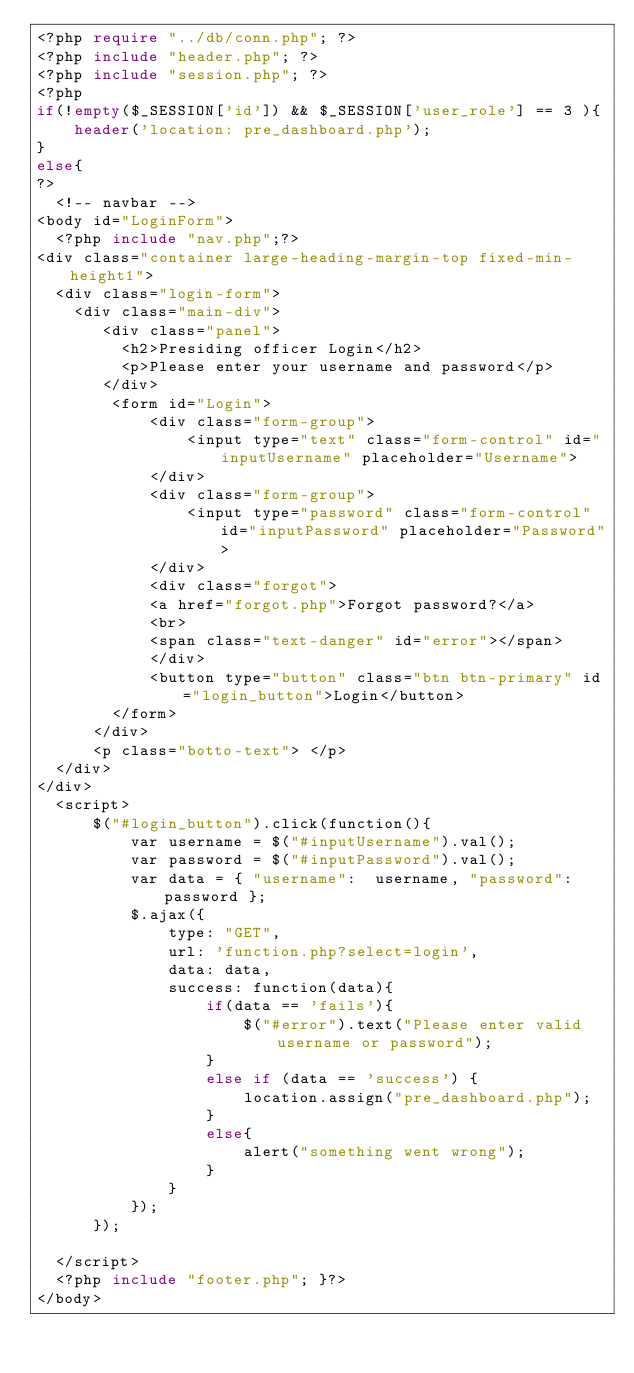<code> <loc_0><loc_0><loc_500><loc_500><_PHP_><?php require "../db/conn.php"; ?>
<?php include "header.php"; ?>
<?php include "session.php"; ?>
<?php
if(!empty($_SESSION['id']) && $_SESSION['user_role'] == 3 ){
    header('location: pre_dashboard.php');
}
else{
?>
  <!-- navbar -->
<body id="LoginForm">
  <?php include "nav.php";?>
<div class="container large-heading-margin-top fixed-min-height1">
  <div class="login-form">
    <div class="main-div">
       <div class="panel">
         <h2>Presiding officer Login</h2>
         <p>Please enter your username and password</p>
       </div>
        <form id="Login">
            <div class="form-group">
                <input type="text" class="form-control" id="inputUsername" placeholder="Username">
            </div>
            <div class="form-group">
                <input type="password" class="form-control" id="inputPassword" placeholder="Password">
            </div>
            <div class="forgot">
            <a href="forgot.php">Forgot password?</a>
            <br>
            <span class="text-danger" id="error"></span>
            </div>
            <button type="button" class="btn btn-primary" id="login_button">Login</button>
        </form>
      </div>
      <p class="botto-text"> </p>
  </div>
</div>
  <script>
      $("#login_button").click(function(){
          var username = $("#inputUsername").val();
          var password = $("#inputPassword").val();
          var data = { "username":  username, "password": password };
          $.ajax({
              type: "GET",
              url: 'function.php?select=login',
              data: data,
              success: function(data){
                  if(data == 'fails'){
                      $("#error").text("Please enter valid username or password");
                  }
                  else if (data == 'success') {
                      location.assign("pre_dashboard.php");
                  }
                  else{
                      alert("something went wrong");
                  }
              }
          });
      });

  </script>
  <?php include "footer.php"; }?>
</body>
</code> 